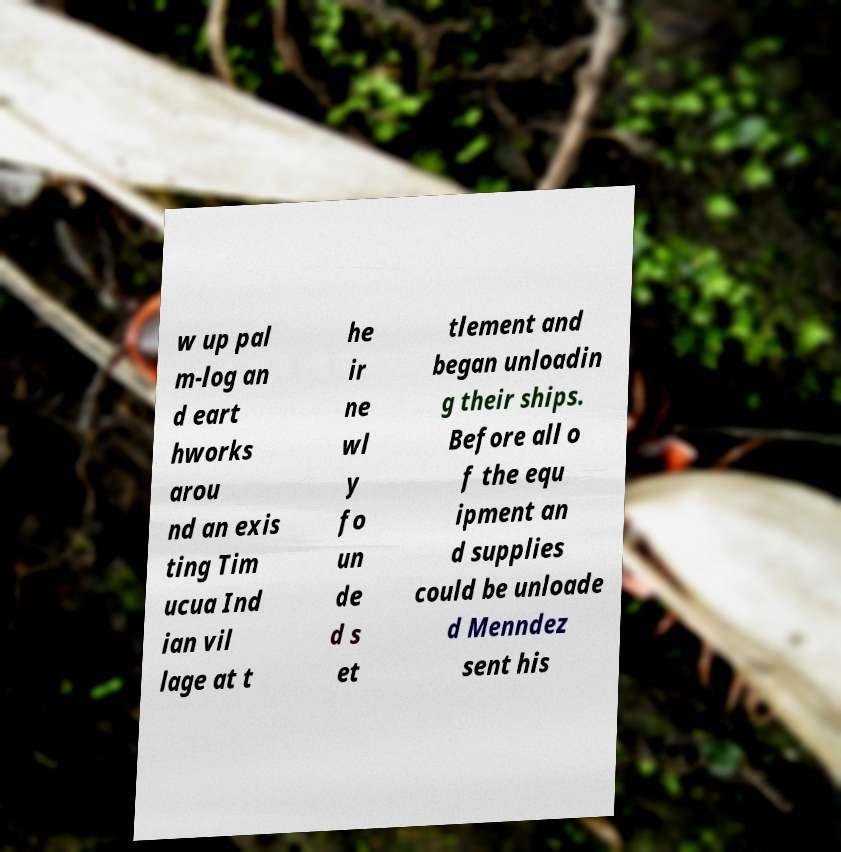Please identify and transcribe the text found in this image. w up pal m-log an d eart hworks arou nd an exis ting Tim ucua Ind ian vil lage at t he ir ne wl y fo un de d s et tlement and began unloadin g their ships. Before all o f the equ ipment an d supplies could be unloade d Menndez sent his 